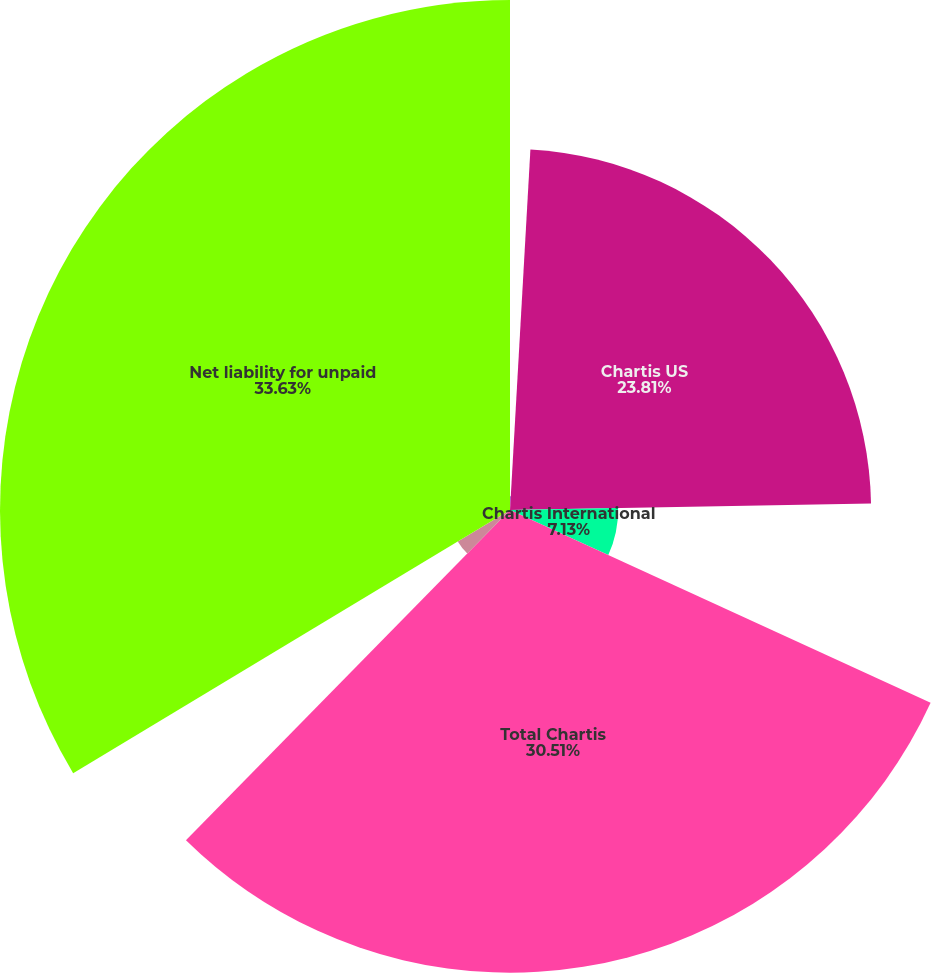Convert chart. <chart><loc_0><loc_0><loc_500><loc_500><pie_chart><fcel>Years Ended December 31 (in<fcel>Chartis US<fcel>Chartis International<fcel>Total Chartis<fcel>Mortgage Guaranty<fcel>Net liability for unpaid<nl><fcel>0.9%<fcel>23.81%<fcel>7.13%<fcel>30.51%<fcel>4.02%<fcel>33.63%<nl></chart> 